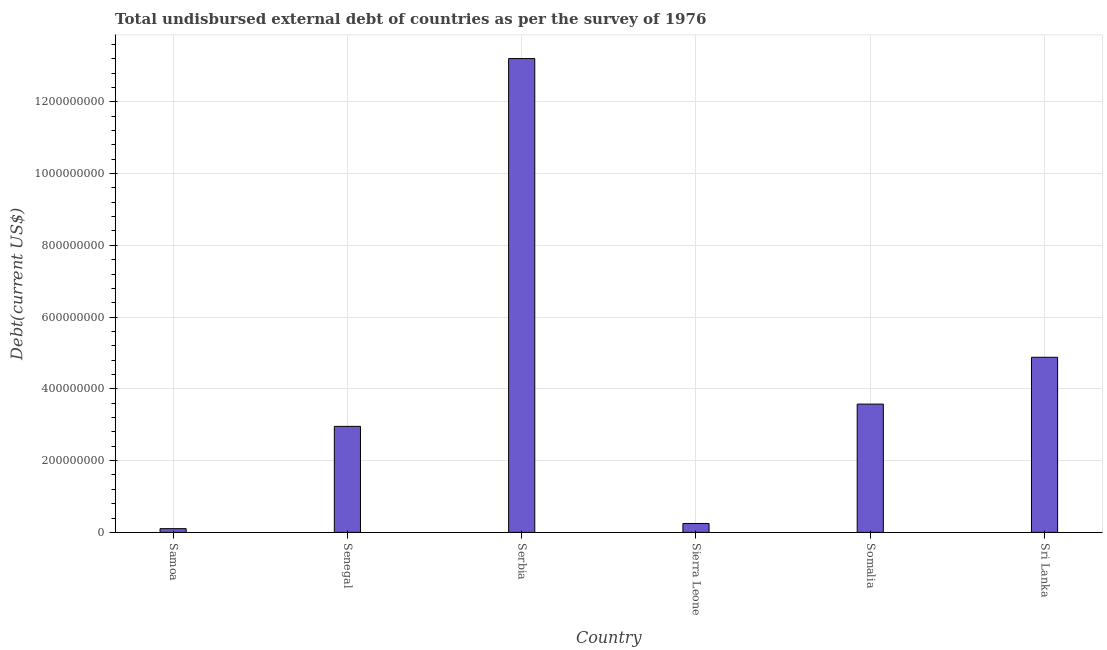Does the graph contain any zero values?
Keep it short and to the point. No. What is the title of the graph?
Offer a terse response. Total undisbursed external debt of countries as per the survey of 1976. What is the label or title of the X-axis?
Keep it short and to the point. Country. What is the label or title of the Y-axis?
Provide a succinct answer. Debt(current US$). What is the total debt in Samoa?
Your answer should be compact. 1.04e+07. Across all countries, what is the maximum total debt?
Give a very brief answer. 1.32e+09. Across all countries, what is the minimum total debt?
Your response must be concise. 1.04e+07. In which country was the total debt maximum?
Offer a very short reply. Serbia. In which country was the total debt minimum?
Offer a very short reply. Samoa. What is the sum of the total debt?
Give a very brief answer. 2.50e+09. What is the difference between the total debt in Senegal and Sri Lanka?
Offer a very short reply. -1.93e+08. What is the average total debt per country?
Provide a short and direct response. 4.16e+08. What is the median total debt?
Offer a terse response. 3.27e+08. In how many countries, is the total debt greater than 720000000 US$?
Ensure brevity in your answer.  1. What is the ratio of the total debt in Samoa to that in Senegal?
Your response must be concise. 0.04. Is the total debt in Samoa less than that in Somalia?
Offer a very short reply. Yes. Is the difference between the total debt in Senegal and Somalia greater than the difference between any two countries?
Make the answer very short. No. What is the difference between the highest and the second highest total debt?
Offer a very short reply. 8.33e+08. What is the difference between the highest and the lowest total debt?
Your answer should be compact. 1.31e+09. What is the difference between two consecutive major ticks on the Y-axis?
Your answer should be compact. 2.00e+08. What is the Debt(current US$) of Samoa?
Give a very brief answer. 1.04e+07. What is the Debt(current US$) in Senegal?
Keep it short and to the point. 2.95e+08. What is the Debt(current US$) in Serbia?
Ensure brevity in your answer.  1.32e+09. What is the Debt(current US$) in Sierra Leone?
Offer a very short reply. 2.48e+07. What is the Debt(current US$) in Somalia?
Keep it short and to the point. 3.58e+08. What is the Debt(current US$) in Sri Lanka?
Keep it short and to the point. 4.88e+08. What is the difference between the Debt(current US$) in Samoa and Senegal?
Ensure brevity in your answer.  -2.85e+08. What is the difference between the Debt(current US$) in Samoa and Serbia?
Your answer should be very brief. -1.31e+09. What is the difference between the Debt(current US$) in Samoa and Sierra Leone?
Ensure brevity in your answer.  -1.44e+07. What is the difference between the Debt(current US$) in Samoa and Somalia?
Ensure brevity in your answer.  -3.47e+08. What is the difference between the Debt(current US$) in Samoa and Sri Lanka?
Ensure brevity in your answer.  -4.78e+08. What is the difference between the Debt(current US$) in Senegal and Serbia?
Provide a succinct answer. -1.03e+09. What is the difference between the Debt(current US$) in Senegal and Sierra Leone?
Your answer should be compact. 2.71e+08. What is the difference between the Debt(current US$) in Senegal and Somalia?
Your answer should be very brief. -6.20e+07. What is the difference between the Debt(current US$) in Senegal and Sri Lanka?
Your response must be concise. -1.93e+08. What is the difference between the Debt(current US$) in Serbia and Sierra Leone?
Offer a terse response. 1.30e+09. What is the difference between the Debt(current US$) in Serbia and Somalia?
Give a very brief answer. 9.63e+08. What is the difference between the Debt(current US$) in Serbia and Sri Lanka?
Keep it short and to the point. 8.33e+08. What is the difference between the Debt(current US$) in Sierra Leone and Somalia?
Your answer should be very brief. -3.33e+08. What is the difference between the Debt(current US$) in Sierra Leone and Sri Lanka?
Ensure brevity in your answer.  -4.63e+08. What is the difference between the Debt(current US$) in Somalia and Sri Lanka?
Offer a terse response. -1.30e+08. What is the ratio of the Debt(current US$) in Samoa to that in Senegal?
Keep it short and to the point. 0.04. What is the ratio of the Debt(current US$) in Samoa to that in Serbia?
Make the answer very short. 0.01. What is the ratio of the Debt(current US$) in Samoa to that in Sierra Leone?
Provide a short and direct response. 0.42. What is the ratio of the Debt(current US$) in Samoa to that in Somalia?
Your response must be concise. 0.03. What is the ratio of the Debt(current US$) in Samoa to that in Sri Lanka?
Offer a very short reply. 0.02. What is the ratio of the Debt(current US$) in Senegal to that in Serbia?
Provide a succinct answer. 0.22. What is the ratio of the Debt(current US$) in Senegal to that in Sierra Leone?
Give a very brief answer. 11.91. What is the ratio of the Debt(current US$) in Senegal to that in Somalia?
Provide a short and direct response. 0.83. What is the ratio of the Debt(current US$) in Senegal to that in Sri Lanka?
Give a very brief answer. 0.6. What is the ratio of the Debt(current US$) in Serbia to that in Sierra Leone?
Your answer should be compact. 53.22. What is the ratio of the Debt(current US$) in Serbia to that in Somalia?
Keep it short and to the point. 3.69. What is the ratio of the Debt(current US$) in Serbia to that in Sri Lanka?
Make the answer very short. 2.71. What is the ratio of the Debt(current US$) in Sierra Leone to that in Somalia?
Offer a terse response. 0.07. What is the ratio of the Debt(current US$) in Sierra Leone to that in Sri Lanka?
Offer a very short reply. 0.05. What is the ratio of the Debt(current US$) in Somalia to that in Sri Lanka?
Give a very brief answer. 0.73. 